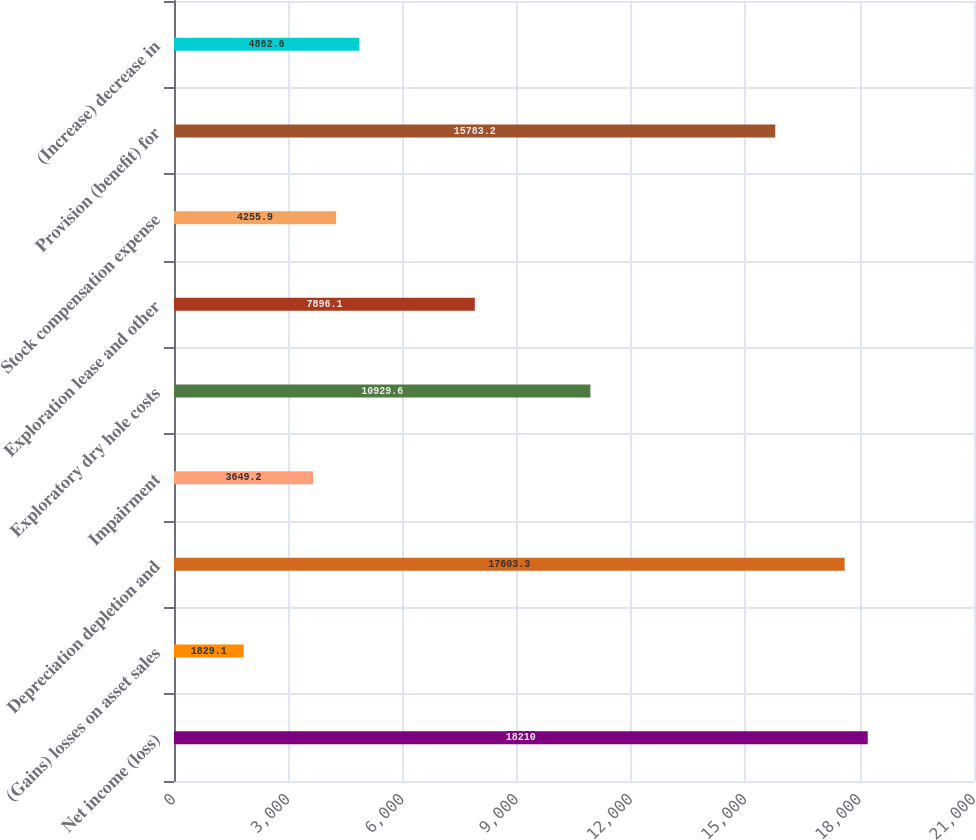Convert chart. <chart><loc_0><loc_0><loc_500><loc_500><bar_chart><fcel>Net income (loss)<fcel>(Gains) losses on asset sales<fcel>Depreciation depletion and<fcel>Impairment<fcel>Exploratory dry hole costs<fcel>Exploration lease and other<fcel>Stock compensation expense<fcel>Provision (benefit) for<fcel>(Increase) decrease in<nl><fcel>18210<fcel>1829.1<fcel>17603.3<fcel>3649.2<fcel>10929.6<fcel>7896.1<fcel>4255.9<fcel>15783.2<fcel>4862.6<nl></chart> 